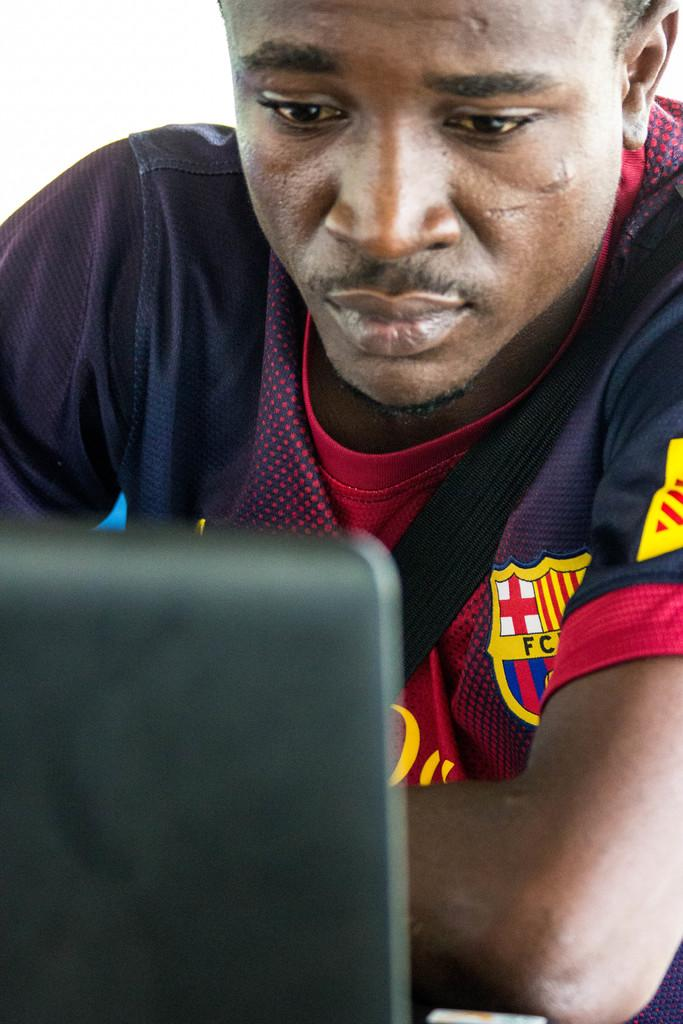<image>
Render a clear and concise summary of the photo. A man has the letters FC on his shirt. 